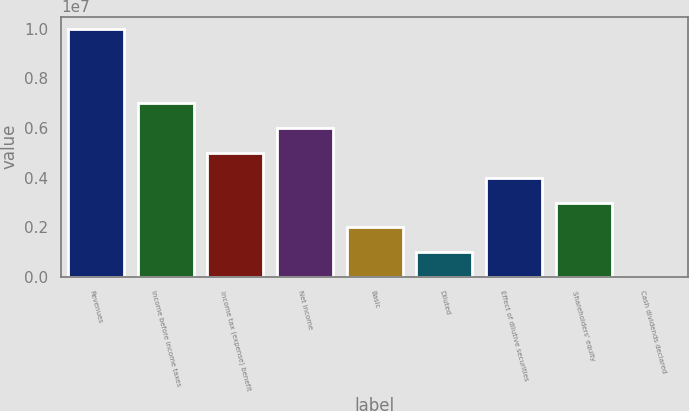Convert chart to OTSL. <chart><loc_0><loc_0><loc_500><loc_500><bar_chart><fcel>Revenues<fcel>Income before income taxes<fcel>Income tax (expense) benefit<fcel>Net income<fcel>Basic<fcel>Diluted<fcel>Effect of dilutive securities<fcel>Shareholders' equity<fcel>Cash dividends declared<nl><fcel>9.98295e+06<fcel>6.98806e+06<fcel>4.99147e+06<fcel>5.98977e+06<fcel>1.99659e+06<fcel>998295<fcel>3.99318e+06<fcel>2.99488e+06<fcel>0.38<nl></chart> 